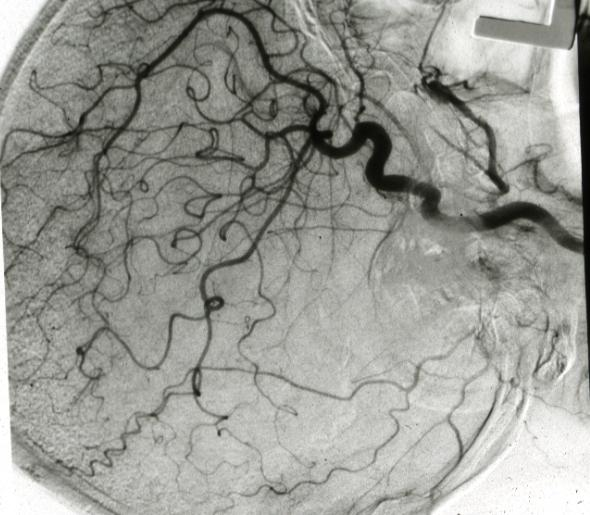what is present?
Answer the question using a single word or phrase. Brain 